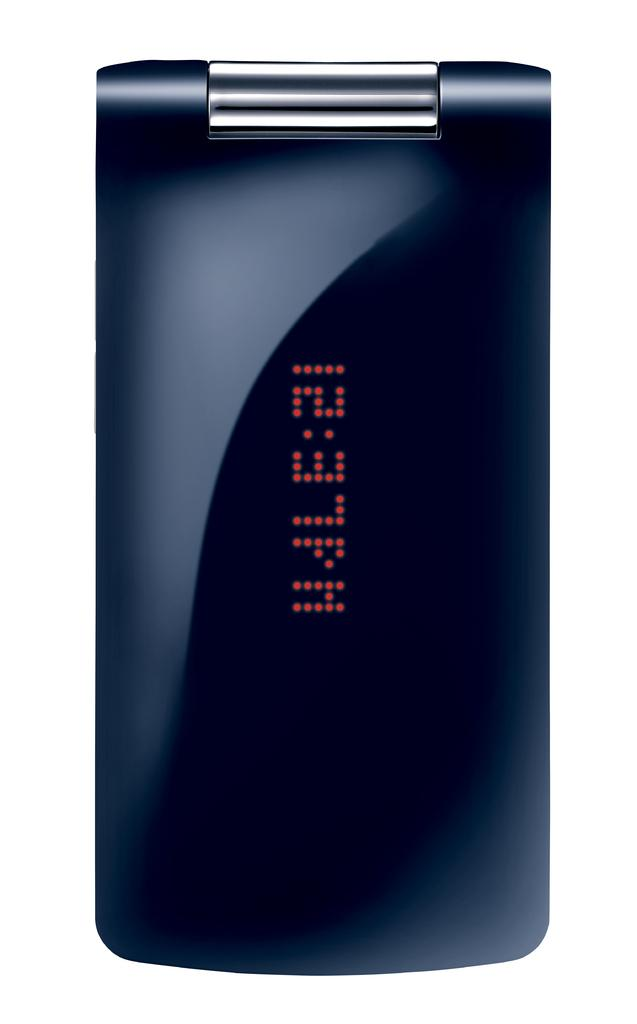<image>
Present a compact description of the photo's key features. The digital readout on the black device says 12:37 pm. 